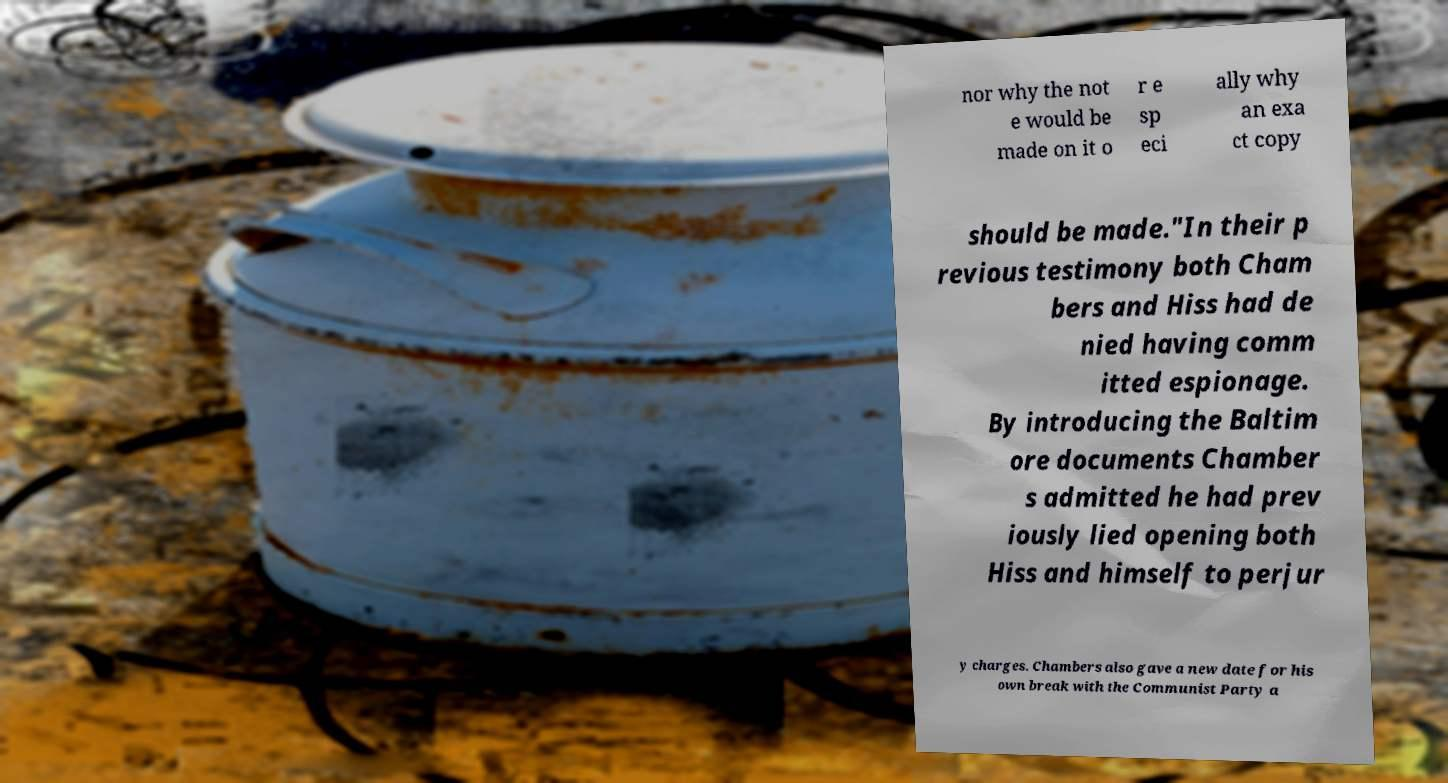What messages or text are displayed in this image? I need them in a readable, typed format. nor why the not e would be made on it o r e sp eci ally why an exa ct copy should be made."In their p revious testimony both Cham bers and Hiss had de nied having comm itted espionage. By introducing the Baltim ore documents Chamber s admitted he had prev iously lied opening both Hiss and himself to perjur y charges. Chambers also gave a new date for his own break with the Communist Party a 